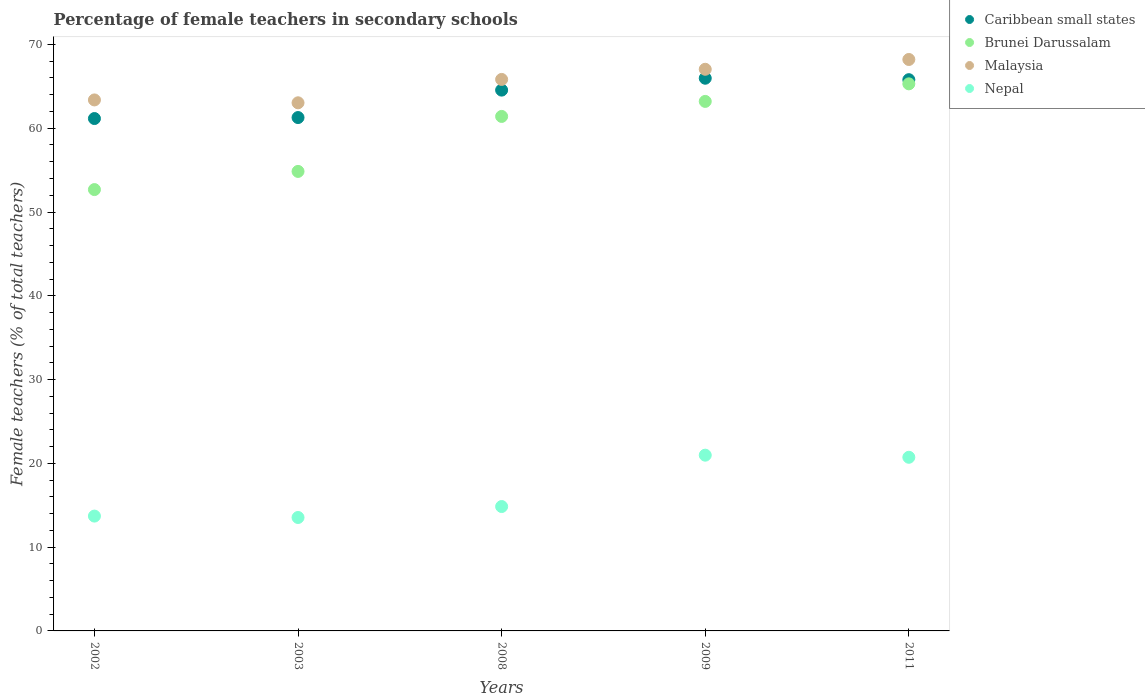How many different coloured dotlines are there?
Keep it short and to the point. 4. Is the number of dotlines equal to the number of legend labels?
Provide a short and direct response. Yes. What is the percentage of female teachers in Nepal in 2008?
Your answer should be very brief. 14.85. Across all years, what is the maximum percentage of female teachers in Malaysia?
Your answer should be compact. 68.21. Across all years, what is the minimum percentage of female teachers in Malaysia?
Keep it short and to the point. 63.04. In which year was the percentage of female teachers in Caribbean small states maximum?
Your answer should be very brief. 2009. What is the total percentage of female teachers in Caribbean small states in the graph?
Make the answer very short. 318.75. What is the difference between the percentage of female teachers in Caribbean small states in 2003 and that in 2008?
Your answer should be compact. -3.28. What is the difference between the percentage of female teachers in Nepal in 2009 and the percentage of female teachers in Malaysia in 2008?
Give a very brief answer. -44.85. What is the average percentage of female teachers in Brunei Darussalam per year?
Offer a very short reply. 59.49. In the year 2009, what is the difference between the percentage of female teachers in Caribbean small states and percentage of female teachers in Nepal?
Keep it short and to the point. 44.99. In how many years, is the percentage of female teachers in Brunei Darussalam greater than 56 %?
Offer a very short reply. 3. What is the ratio of the percentage of female teachers in Nepal in 2002 to that in 2008?
Keep it short and to the point. 0.92. Is the percentage of female teachers in Caribbean small states in 2002 less than that in 2009?
Make the answer very short. Yes. Is the difference between the percentage of female teachers in Caribbean small states in 2003 and 2009 greater than the difference between the percentage of female teachers in Nepal in 2003 and 2009?
Provide a succinct answer. Yes. What is the difference between the highest and the second highest percentage of female teachers in Malaysia?
Provide a succinct answer. 1.17. What is the difference between the highest and the lowest percentage of female teachers in Nepal?
Provide a short and direct response. 7.44. In how many years, is the percentage of female teachers in Malaysia greater than the average percentage of female teachers in Malaysia taken over all years?
Make the answer very short. 3. Is the sum of the percentage of female teachers in Malaysia in 2008 and 2009 greater than the maximum percentage of female teachers in Brunei Darussalam across all years?
Your response must be concise. Yes. Is it the case that in every year, the sum of the percentage of female teachers in Nepal and percentage of female teachers in Malaysia  is greater than the percentage of female teachers in Brunei Darussalam?
Make the answer very short. Yes. How many dotlines are there?
Your answer should be compact. 4. How many years are there in the graph?
Your answer should be compact. 5. Are the values on the major ticks of Y-axis written in scientific E-notation?
Offer a terse response. No. What is the title of the graph?
Give a very brief answer. Percentage of female teachers in secondary schools. Does "Costa Rica" appear as one of the legend labels in the graph?
Provide a succinct answer. No. What is the label or title of the Y-axis?
Make the answer very short. Female teachers (% of total teachers). What is the Female teachers (% of total teachers) in Caribbean small states in 2002?
Ensure brevity in your answer.  61.16. What is the Female teachers (% of total teachers) of Brunei Darussalam in 2002?
Your response must be concise. 52.68. What is the Female teachers (% of total teachers) of Malaysia in 2002?
Your answer should be very brief. 63.38. What is the Female teachers (% of total teachers) of Nepal in 2002?
Your answer should be compact. 13.71. What is the Female teachers (% of total teachers) of Caribbean small states in 2003?
Your answer should be very brief. 61.28. What is the Female teachers (% of total teachers) in Brunei Darussalam in 2003?
Offer a very short reply. 54.85. What is the Female teachers (% of total teachers) in Malaysia in 2003?
Make the answer very short. 63.04. What is the Female teachers (% of total teachers) of Nepal in 2003?
Ensure brevity in your answer.  13.54. What is the Female teachers (% of total teachers) in Caribbean small states in 2008?
Provide a short and direct response. 64.55. What is the Female teachers (% of total teachers) of Brunei Darussalam in 2008?
Provide a short and direct response. 61.41. What is the Female teachers (% of total teachers) in Malaysia in 2008?
Provide a short and direct response. 65.83. What is the Female teachers (% of total teachers) of Nepal in 2008?
Give a very brief answer. 14.85. What is the Female teachers (% of total teachers) in Caribbean small states in 2009?
Your response must be concise. 65.97. What is the Female teachers (% of total teachers) of Brunei Darussalam in 2009?
Make the answer very short. 63.2. What is the Female teachers (% of total teachers) of Malaysia in 2009?
Offer a terse response. 67.04. What is the Female teachers (% of total teachers) of Nepal in 2009?
Provide a succinct answer. 20.98. What is the Female teachers (% of total teachers) of Caribbean small states in 2011?
Keep it short and to the point. 65.8. What is the Female teachers (% of total teachers) in Brunei Darussalam in 2011?
Make the answer very short. 65.3. What is the Female teachers (% of total teachers) in Malaysia in 2011?
Give a very brief answer. 68.21. What is the Female teachers (% of total teachers) in Nepal in 2011?
Ensure brevity in your answer.  20.73. Across all years, what is the maximum Female teachers (% of total teachers) of Caribbean small states?
Offer a very short reply. 65.97. Across all years, what is the maximum Female teachers (% of total teachers) of Brunei Darussalam?
Offer a very short reply. 65.3. Across all years, what is the maximum Female teachers (% of total teachers) in Malaysia?
Make the answer very short. 68.21. Across all years, what is the maximum Female teachers (% of total teachers) in Nepal?
Provide a succinct answer. 20.98. Across all years, what is the minimum Female teachers (% of total teachers) of Caribbean small states?
Provide a succinct answer. 61.16. Across all years, what is the minimum Female teachers (% of total teachers) of Brunei Darussalam?
Your answer should be very brief. 52.68. Across all years, what is the minimum Female teachers (% of total teachers) in Malaysia?
Provide a short and direct response. 63.04. Across all years, what is the minimum Female teachers (% of total teachers) of Nepal?
Make the answer very short. 13.54. What is the total Female teachers (% of total teachers) in Caribbean small states in the graph?
Offer a terse response. 318.75. What is the total Female teachers (% of total teachers) of Brunei Darussalam in the graph?
Ensure brevity in your answer.  297.44. What is the total Female teachers (% of total teachers) in Malaysia in the graph?
Provide a succinct answer. 327.49. What is the total Female teachers (% of total teachers) of Nepal in the graph?
Your answer should be compact. 83.8. What is the difference between the Female teachers (% of total teachers) in Caribbean small states in 2002 and that in 2003?
Your response must be concise. -0.12. What is the difference between the Female teachers (% of total teachers) of Brunei Darussalam in 2002 and that in 2003?
Provide a short and direct response. -2.17. What is the difference between the Female teachers (% of total teachers) of Malaysia in 2002 and that in 2003?
Your answer should be very brief. 0.34. What is the difference between the Female teachers (% of total teachers) of Nepal in 2002 and that in 2003?
Your answer should be compact. 0.17. What is the difference between the Female teachers (% of total teachers) in Caribbean small states in 2002 and that in 2008?
Offer a terse response. -3.39. What is the difference between the Female teachers (% of total teachers) in Brunei Darussalam in 2002 and that in 2008?
Provide a succinct answer. -8.73. What is the difference between the Female teachers (% of total teachers) of Malaysia in 2002 and that in 2008?
Offer a terse response. -2.45. What is the difference between the Female teachers (% of total teachers) in Nepal in 2002 and that in 2008?
Offer a terse response. -1.14. What is the difference between the Female teachers (% of total teachers) in Caribbean small states in 2002 and that in 2009?
Make the answer very short. -4.81. What is the difference between the Female teachers (% of total teachers) of Brunei Darussalam in 2002 and that in 2009?
Provide a succinct answer. -10.52. What is the difference between the Female teachers (% of total teachers) of Malaysia in 2002 and that in 2009?
Make the answer very short. -3.66. What is the difference between the Female teachers (% of total teachers) of Nepal in 2002 and that in 2009?
Ensure brevity in your answer.  -7.27. What is the difference between the Female teachers (% of total teachers) in Caribbean small states in 2002 and that in 2011?
Give a very brief answer. -4.64. What is the difference between the Female teachers (% of total teachers) of Brunei Darussalam in 2002 and that in 2011?
Provide a short and direct response. -12.62. What is the difference between the Female teachers (% of total teachers) in Malaysia in 2002 and that in 2011?
Ensure brevity in your answer.  -4.83. What is the difference between the Female teachers (% of total teachers) in Nepal in 2002 and that in 2011?
Give a very brief answer. -7.02. What is the difference between the Female teachers (% of total teachers) of Caribbean small states in 2003 and that in 2008?
Your answer should be very brief. -3.28. What is the difference between the Female teachers (% of total teachers) in Brunei Darussalam in 2003 and that in 2008?
Make the answer very short. -6.56. What is the difference between the Female teachers (% of total teachers) of Malaysia in 2003 and that in 2008?
Your answer should be very brief. -2.79. What is the difference between the Female teachers (% of total teachers) of Nepal in 2003 and that in 2008?
Ensure brevity in your answer.  -1.31. What is the difference between the Female teachers (% of total teachers) in Caribbean small states in 2003 and that in 2009?
Offer a terse response. -4.69. What is the difference between the Female teachers (% of total teachers) in Brunei Darussalam in 2003 and that in 2009?
Provide a short and direct response. -8.36. What is the difference between the Female teachers (% of total teachers) of Malaysia in 2003 and that in 2009?
Provide a short and direct response. -4. What is the difference between the Female teachers (% of total teachers) of Nepal in 2003 and that in 2009?
Offer a terse response. -7.44. What is the difference between the Female teachers (% of total teachers) of Caribbean small states in 2003 and that in 2011?
Make the answer very short. -4.52. What is the difference between the Female teachers (% of total teachers) in Brunei Darussalam in 2003 and that in 2011?
Offer a terse response. -10.45. What is the difference between the Female teachers (% of total teachers) in Malaysia in 2003 and that in 2011?
Ensure brevity in your answer.  -5.17. What is the difference between the Female teachers (% of total teachers) in Nepal in 2003 and that in 2011?
Make the answer very short. -7.19. What is the difference between the Female teachers (% of total teachers) of Caribbean small states in 2008 and that in 2009?
Give a very brief answer. -1.42. What is the difference between the Female teachers (% of total teachers) in Brunei Darussalam in 2008 and that in 2009?
Your answer should be compact. -1.79. What is the difference between the Female teachers (% of total teachers) of Malaysia in 2008 and that in 2009?
Your answer should be very brief. -1.21. What is the difference between the Female teachers (% of total teachers) in Nepal in 2008 and that in 2009?
Make the answer very short. -6.13. What is the difference between the Female teachers (% of total teachers) in Caribbean small states in 2008 and that in 2011?
Your answer should be compact. -1.25. What is the difference between the Female teachers (% of total teachers) in Brunei Darussalam in 2008 and that in 2011?
Ensure brevity in your answer.  -3.89. What is the difference between the Female teachers (% of total teachers) in Malaysia in 2008 and that in 2011?
Ensure brevity in your answer.  -2.38. What is the difference between the Female teachers (% of total teachers) in Nepal in 2008 and that in 2011?
Your response must be concise. -5.88. What is the difference between the Female teachers (% of total teachers) in Caribbean small states in 2009 and that in 2011?
Keep it short and to the point. 0.17. What is the difference between the Female teachers (% of total teachers) of Brunei Darussalam in 2009 and that in 2011?
Your response must be concise. -2.1. What is the difference between the Female teachers (% of total teachers) of Malaysia in 2009 and that in 2011?
Keep it short and to the point. -1.17. What is the difference between the Female teachers (% of total teachers) in Nepal in 2009 and that in 2011?
Provide a succinct answer. 0.25. What is the difference between the Female teachers (% of total teachers) of Caribbean small states in 2002 and the Female teachers (% of total teachers) of Brunei Darussalam in 2003?
Your answer should be very brief. 6.31. What is the difference between the Female teachers (% of total teachers) in Caribbean small states in 2002 and the Female teachers (% of total teachers) in Malaysia in 2003?
Keep it short and to the point. -1.88. What is the difference between the Female teachers (% of total teachers) of Caribbean small states in 2002 and the Female teachers (% of total teachers) of Nepal in 2003?
Keep it short and to the point. 47.62. What is the difference between the Female teachers (% of total teachers) of Brunei Darussalam in 2002 and the Female teachers (% of total teachers) of Malaysia in 2003?
Provide a short and direct response. -10.36. What is the difference between the Female teachers (% of total teachers) in Brunei Darussalam in 2002 and the Female teachers (% of total teachers) in Nepal in 2003?
Your response must be concise. 39.14. What is the difference between the Female teachers (% of total teachers) in Malaysia in 2002 and the Female teachers (% of total teachers) in Nepal in 2003?
Keep it short and to the point. 49.84. What is the difference between the Female teachers (% of total teachers) of Caribbean small states in 2002 and the Female teachers (% of total teachers) of Brunei Darussalam in 2008?
Your response must be concise. -0.25. What is the difference between the Female teachers (% of total teachers) in Caribbean small states in 2002 and the Female teachers (% of total teachers) in Malaysia in 2008?
Ensure brevity in your answer.  -4.67. What is the difference between the Female teachers (% of total teachers) in Caribbean small states in 2002 and the Female teachers (% of total teachers) in Nepal in 2008?
Make the answer very short. 46.31. What is the difference between the Female teachers (% of total teachers) in Brunei Darussalam in 2002 and the Female teachers (% of total teachers) in Malaysia in 2008?
Give a very brief answer. -13.15. What is the difference between the Female teachers (% of total teachers) of Brunei Darussalam in 2002 and the Female teachers (% of total teachers) of Nepal in 2008?
Ensure brevity in your answer.  37.83. What is the difference between the Female teachers (% of total teachers) in Malaysia in 2002 and the Female teachers (% of total teachers) in Nepal in 2008?
Offer a terse response. 48.53. What is the difference between the Female teachers (% of total teachers) in Caribbean small states in 2002 and the Female teachers (% of total teachers) in Brunei Darussalam in 2009?
Provide a short and direct response. -2.05. What is the difference between the Female teachers (% of total teachers) in Caribbean small states in 2002 and the Female teachers (% of total teachers) in Malaysia in 2009?
Offer a very short reply. -5.88. What is the difference between the Female teachers (% of total teachers) of Caribbean small states in 2002 and the Female teachers (% of total teachers) of Nepal in 2009?
Your answer should be very brief. 40.18. What is the difference between the Female teachers (% of total teachers) in Brunei Darussalam in 2002 and the Female teachers (% of total teachers) in Malaysia in 2009?
Your response must be concise. -14.36. What is the difference between the Female teachers (% of total teachers) of Brunei Darussalam in 2002 and the Female teachers (% of total teachers) of Nepal in 2009?
Your response must be concise. 31.7. What is the difference between the Female teachers (% of total teachers) of Malaysia in 2002 and the Female teachers (% of total teachers) of Nepal in 2009?
Give a very brief answer. 42.4. What is the difference between the Female teachers (% of total teachers) of Caribbean small states in 2002 and the Female teachers (% of total teachers) of Brunei Darussalam in 2011?
Your answer should be very brief. -4.14. What is the difference between the Female teachers (% of total teachers) of Caribbean small states in 2002 and the Female teachers (% of total teachers) of Malaysia in 2011?
Provide a short and direct response. -7.05. What is the difference between the Female teachers (% of total teachers) in Caribbean small states in 2002 and the Female teachers (% of total teachers) in Nepal in 2011?
Give a very brief answer. 40.43. What is the difference between the Female teachers (% of total teachers) in Brunei Darussalam in 2002 and the Female teachers (% of total teachers) in Malaysia in 2011?
Your response must be concise. -15.53. What is the difference between the Female teachers (% of total teachers) in Brunei Darussalam in 2002 and the Female teachers (% of total teachers) in Nepal in 2011?
Make the answer very short. 31.95. What is the difference between the Female teachers (% of total teachers) of Malaysia in 2002 and the Female teachers (% of total teachers) of Nepal in 2011?
Make the answer very short. 42.65. What is the difference between the Female teachers (% of total teachers) of Caribbean small states in 2003 and the Female teachers (% of total teachers) of Brunei Darussalam in 2008?
Give a very brief answer. -0.13. What is the difference between the Female teachers (% of total teachers) of Caribbean small states in 2003 and the Female teachers (% of total teachers) of Malaysia in 2008?
Provide a short and direct response. -4.55. What is the difference between the Female teachers (% of total teachers) in Caribbean small states in 2003 and the Female teachers (% of total teachers) in Nepal in 2008?
Your answer should be very brief. 46.43. What is the difference between the Female teachers (% of total teachers) in Brunei Darussalam in 2003 and the Female teachers (% of total teachers) in Malaysia in 2008?
Your answer should be very brief. -10.98. What is the difference between the Female teachers (% of total teachers) of Brunei Darussalam in 2003 and the Female teachers (% of total teachers) of Nepal in 2008?
Make the answer very short. 40. What is the difference between the Female teachers (% of total teachers) of Malaysia in 2003 and the Female teachers (% of total teachers) of Nepal in 2008?
Provide a short and direct response. 48.19. What is the difference between the Female teachers (% of total teachers) in Caribbean small states in 2003 and the Female teachers (% of total teachers) in Brunei Darussalam in 2009?
Ensure brevity in your answer.  -1.93. What is the difference between the Female teachers (% of total teachers) in Caribbean small states in 2003 and the Female teachers (% of total teachers) in Malaysia in 2009?
Ensure brevity in your answer.  -5.76. What is the difference between the Female teachers (% of total teachers) of Caribbean small states in 2003 and the Female teachers (% of total teachers) of Nepal in 2009?
Give a very brief answer. 40.3. What is the difference between the Female teachers (% of total teachers) of Brunei Darussalam in 2003 and the Female teachers (% of total teachers) of Malaysia in 2009?
Your answer should be very brief. -12.19. What is the difference between the Female teachers (% of total teachers) of Brunei Darussalam in 2003 and the Female teachers (% of total teachers) of Nepal in 2009?
Make the answer very short. 33.87. What is the difference between the Female teachers (% of total teachers) in Malaysia in 2003 and the Female teachers (% of total teachers) in Nepal in 2009?
Your answer should be very brief. 42.06. What is the difference between the Female teachers (% of total teachers) of Caribbean small states in 2003 and the Female teachers (% of total teachers) of Brunei Darussalam in 2011?
Your answer should be compact. -4.02. What is the difference between the Female teachers (% of total teachers) in Caribbean small states in 2003 and the Female teachers (% of total teachers) in Malaysia in 2011?
Provide a short and direct response. -6.93. What is the difference between the Female teachers (% of total teachers) in Caribbean small states in 2003 and the Female teachers (% of total teachers) in Nepal in 2011?
Provide a succinct answer. 40.55. What is the difference between the Female teachers (% of total teachers) of Brunei Darussalam in 2003 and the Female teachers (% of total teachers) of Malaysia in 2011?
Ensure brevity in your answer.  -13.36. What is the difference between the Female teachers (% of total teachers) in Brunei Darussalam in 2003 and the Female teachers (% of total teachers) in Nepal in 2011?
Ensure brevity in your answer.  34.12. What is the difference between the Female teachers (% of total teachers) in Malaysia in 2003 and the Female teachers (% of total teachers) in Nepal in 2011?
Your answer should be very brief. 42.31. What is the difference between the Female teachers (% of total teachers) of Caribbean small states in 2008 and the Female teachers (% of total teachers) of Brunei Darussalam in 2009?
Offer a very short reply. 1.35. What is the difference between the Female teachers (% of total teachers) of Caribbean small states in 2008 and the Female teachers (% of total teachers) of Malaysia in 2009?
Give a very brief answer. -2.49. What is the difference between the Female teachers (% of total teachers) in Caribbean small states in 2008 and the Female teachers (% of total teachers) in Nepal in 2009?
Provide a short and direct response. 43.57. What is the difference between the Female teachers (% of total teachers) of Brunei Darussalam in 2008 and the Female teachers (% of total teachers) of Malaysia in 2009?
Your answer should be compact. -5.63. What is the difference between the Female teachers (% of total teachers) of Brunei Darussalam in 2008 and the Female teachers (% of total teachers) of Nepal in 2009?
Your answer should be compact. 40.43. What is the difference between the Female teachers (% of total teachers) of Malaysia in 2008 and the Female teachers (% of total teachers) of Nepal in 2009?
Your response must be concise. 44.85. What is the difference between the Female teachers (% of total teachers) in Caribbean small states in 2008 and the Female teachers (% of total teachers) in Brunei Darussalam in 2011?
Your answer should be compact. -0.75. What is the difference between the Female teachers (% of total teachers) of Caribbean small states in 2008 and the Female teachers (% of total teachers) of Malaysia in 2011?
Provide a succinct answer. -3.66. What is the difference between the Female teachers (% of total teachers) in Caribbean small states in 2008 and the Female teachers (% of total teachers) in Nepal in 2011?
Make the answer very short. 43.83. What is the difference between the Female teachers (% of total teachers) of Brunei Darussalam in 2008 and the Female teachers (% of total teachers) of Malaysia in 2011?
Make the answer very short. -6.8. What is the difference between the Female teachers (% of total teachers) in Brunei Darussalam in 2008 and the Female teachers (% of total teachers) in Nepal in 2011?
Your answer should be very brief. 40.68. What is the difference between the Female teachers (% of total teachers) in Malaysia in 2008 and the Female teachers (% of total teachers) in Nepal in 2011?
Keep it short and to the point. 45.1. What is the difference between the Female teachers (% of total teachers) in Caribbean small states in 2009 and the Female teachers (% of total teachers) in Brunei Darussalam in 2011?
Ensure brevity in your answer.  0.67. What is the difference between the Female teachers (% of total teachers) in Caribbean small states in 2009 and the Female teachers (% of total teachers) in Malaysia in 2011?
Your answer should be compact. -2.24. What is the difference between the Female teachers (% of total teachers) of Caribbean small states in 2009 and the Female teachers (% of total teachers) of Nepal in 2011?
Your answer should be very brief. 45.24. What is the difference between the Female teachers (% of total teachers) of Brunei Darussalam in 2009 and the Female teachers (% of total teachers) of Malaysia in 2011?
Provide a short and direct response. -5. What is the difference between the Female teachers (% of total teachers) of Brunei Darussalam in 2009 and the Female teachers (% of total teachers) of Nepal in 2011?
Your answer should be compact. 42.48. What is the difference between the Female teachers (% of total teachers) in Malaysia in 2009 and the Female teachers (% of total teachers) in Nepal in 2011?
Your answer should be compact. 46.31. What is the average Female teachers (% of total teachers) of Caribbean small states per year?
Ensure brevity in your answer.  63.75. What is the average Female teachers (% of total teachers) in Brunei Darussalam per year?
Keep it short and to the point. 59.49. What is the average Female teachers (% of total teachers) in Malaysia per year?
Make the answer very short. 65.5. What is the average Female teachers (% of total teachers) of Nepal per year?
Give a very brief answer. 16.76. In the year 2002, what is the difference between the Female teachers (% of total teachers) in Caribbean small states and Female teachers (% of total teachers) in Brunei Darussalam?
Your answer should be very brief. 8.48. In the year 2002, what is the difference between the Female teachers (% of total teachers) in Caribbean small states and Female teachers (% of total teachers) in Malaysia?
Your answer should be very brief. -2.22. In the year 2002, what is the difference between the Female teachers (% of total teachers) of Caribbean small states and Female teachers (% of total teachers) of Nepal?
Provide a short and direct response. 47.45. In the year 2002, what is the difference between the Female teachers (% of total teachers) of Brunei Darussalam and Female teachers (% of total teachers) of Malaysia?
Provide a short and direct response. -10.7. In the year 2002, what is the difference between the Female teachers (% of total teachers) of Brunei Darussalam and Female teachers (% of total teachers) of Nepal?
Provide a short and direct response. 38.97. In the year 2002, what is the difference between the Female teachers (% of total teachers) in Malaysia and Female teachers (% of total teachers) in Nepal?
Your response must be concise. 49.67. In the year 2003, what is the difference between the Female teachers (% of total teachers) in Caribbean small states and Female teachers (% of total teachers) in Brunei Darussalam?
Ensure brevity in your answer.  6.43. In the year 2003, what is the difference between the Female teachers (% of total teachers) of Caribbean small states and Female teachers (% of total teachers) of Malaysia?
Offer a very short reply. -1.76. In the year 2003, what is the difference between the Female teachers (% of total teachers) in Caribbean small states and Female teachers (% of total teachers) in Nepal?
Offer a terse response. 47.74. In the year 2003, what is the difference between the Female teachers (% of total teachers) of Brunei Darussalam and Female teachers (% of total teachers) of Malaysia?
Provide a succinct answer. -8.19. In the year 2003, what is the difference between the Female teachers (% of total teachers) in Brunei Darussalam and Female teachers (% of total teachers) in Nepal?
Ensure brevity in your answer.  41.31. In the year 2003, what is the difference between the Female teachers (% of total teachers) of Malaysia and Female teachers (% of total teachers) of Nepal?
Ensure brevity in your answer.  49.5. In the year 2008, what is the difference between the Female teachers (% of total teachers) of Caribbean small states and Female teachers (% of total teachers) of Brunei Darussalam?
Keep it short and to the point. 3.14. In the year 2008, what is the difference between the Female teachers (% of total teachers) in Caribbean small states and Female teachers (% of total teachers) in Malaysia?
Your answer should be compact. -1.27. In the year 2008, what is the difference between the Female teachers (% of total teachers) in Caribbean small states and Female teachers (% of total teachers) in Nepal?
Keep it short and to the point. 49.7. In the year 2008, what is the difference between the Female teachers (% of total teachers) of Brunei Darussalam and Female teachers (% of total teachers) of Malaysia?
Provide a succinct answer. -4.42. In the year 2008, what is the difference between the Female teachers (% of total teachers) in Brunei Darussalam and Female teachers (% of total teachers) in Nepal?
Make the answer very short. 46.56. In the year 2008, what is the difference between the Female teachers (% of total teachers) of Malaysia and Female teachers (% of total teachers) of Nepal?
Offer a very short reply. 50.98. In the year 2009, what is the difference between the Female teachers (% of total teachers) of Caribbean small states and Female teachers (% of total teachers) of Brunei Darussalam?
Provide a succinct answer. 2.77. In the year 2009, what is the difference between the Female teachers (% of total teachers) in Caribbean small states and Female teachers (% of total teachers) in Malaysia?
Your answer should be compact. -1.07. In the year 2009, what is the difference between the Female teachers (% of total teachers) of Caribbean small states and Female teachers (% of total teachers) of Nepal?
Your answer should be very brief. 44.99. In the year 2009, what is the difference between the Female teachers (% of total teachers) of Brunei Darussalam and Female teachers (% of total teachers) of Malaysia?
Offer a terse response. -3.83. In the year 2009, what is the difference between the Female teachers (% of total teachers) in Brunei Darussalam and Female teachers (% of total teachers) in Nepal?
Keep it short and to the point. 42.23. In the year 2009, what is the difference between the Female teachers (% of total teachers) in Malaysia and Female teachers (% of total teachers) in Nepal?
Offer a very short reply. 46.06. In the year 2011, what is the difference between the Female teachers (% of total teachers) of Caribbean small states and Female teachers (% of total teachers) of Brunei Darussalam?
Keep it short and to the point. 0.5. In the year 2011, what is the difference between the Female teachers (% of total teachers) in Caribbean small states and Female teachers (% of total teachers) in Malaysia?
Your answer should be compact. -2.41. In the year 2011, what is the difference between the Female teachers (% of total teachers) in Caribbean small states and Female teachers (% of total teachers) in Nepal?
Offer a very short reply. 45.07. In the year 2011, what is the difference between the Female teachers (% of total teachers) in Brunei Darussalam and Female teachers (% of total teachers) in Malaysia?
Ensure brevity in your answer.  -2.91. In the year 2011, what is the difference between the Female teachers (% of total teachers) in Brunei Darussalam and Female teachers (% of total teachers) in Nepal?
Offer a terse response. 44.57. In the year 2011, what is the difference between the Female teachers (% of total teachers) of Malaysia and Female teachers (% of total teachers) of Nepal?
Keep it short and to the point. 47.48. What is the ratio of the Female teachers (% of total teachers) in Brunei Darussalam in 2002 to that in 2003?
Give a very brief answer. 0.96. What is the ratio of the Female teachers (% of total teachers) of Malaysia in 2002 to that in 2003?
Keep it short and to the point. 1.01. What is the ratio of the Female teachers (% of total teachers) in Nepal in 2002 to that in 2003?
Your answer should be compact. 1.01. What is the ratio of the Female teachers (% of total teachers) of Caribbean small states in 2002 to that in 2008?
Offer a very short reply. 0.95. What is the ratio of the Female teachers (% of total teachers) in Brunei Darussalam in 2002 to that in 2008?
Your answer should be compact. 0.86. What is the ratio of the Female teachers (% of total teachers) in Malaysia in 2002 to that in 2008?
Offer a very short reply. 0.96. What is the ratio of the Female teachers (% of total teachers) in Nepal in 2002 to that in 2008?
Ensure brevity in your answer.  0.92. What is the ratio of the Female teachers (% of total teachers) in Caribbean small states in 2002 to that in 2009?
Provide a succinct answer. 0.93. What is the ratio of the Female teachers (% of total teachers) in Brunei Darussalam in 2002 to that in 2009?
Your answer should be compact. 0.83. What is the ratio of the Female teachers (% of total teachers) in Malaysia in 2002 to that in 2009?
Your answer should be very brief. 0.95. What is the ratio of the Female teachers (% of total teachers) of Nepal in 2002 to that in 2009?
Offer a very short reply. 0.65. What is the ratio of the Female teachers (% of total teachers) in Caribbean small states in 2002 to that in 2011?
Give a very brief answer. 0.93. What is the ratio of the Female teachers (% of total teachers) in Brunei Darussalam in 2002 to that in 2011?
Your response must be concise. 0.81. What is the ratio of the Female teachers (% of total teachers) in Malaysia in 2002 to that in 2011?
Offer a very short reply. 0.93. What is the ratio of the Female teachers (% of total teachers) of Nepal in 2002 to that in 2011?
Offer a very short reply. 0.66. What is the ratio of the Female teachers (% of total teachers) in Caribbean small states in 2003 to that in 2008?
Keep it short and to the point. 0.95. What is the ratio of the Female teachers (% of total teachers) of Brunei Darussalam in 2003 to that in 2008?
Offer a terse response. 0.89. What is the ratio of the Female teachers (% of total teachers) of Malaysia in 2003 to that in 2008?
Your response must be concise. 0.96. What is the ratio of the Female teachers (% of total teachers) in Nepal in 2003 to that in 2008?
Your answer should be very brief. 0.91. What is the ratio of the Female teachers (% of total teachers) of Caribbean small states in 2003 to that in 2009?
Your answer should be compact. 0.93. What is the ratio of the Female teachers (% of total teachers) in Brunei Darussalam in 2003 to that in 2009?
Give a very brief answer. 0.87. What is the ratio of the Female teachers (% of total teachers) in Malaysia in 2003 to that in 2009?
Offer a terse response. 0.94. What is the ratio of the Female teachers (% of total teachers) in Nepal in 2003 to that in 2009?
Offer a terse response. 0.65. What is the ratio of the Female teachers (% of total teachers) in Caribbean small states in 2003 to that in 2011?
Offer a very short reply. 0.93. What is the ratio of the Female teachers (% of total teachers) of Brunei Darussalam in 2003 to that in 2011?
Offer a terse response. 0.84. What is the ratio of the Female teachers (% of total teachers) of Malaysia in 2003 to that in 2011?
Give a very brief answer. 0.92. What is the ratio of the Female teachers (% of total teachers) in Nepal in 2003 to that in 2011?
Ensure brevity in your answer.  0.65. What is the ratio of the Female teachers (% of total teachers) of Caribbean small states in 2008 to that in 2009?
Give a very brief answer. 0.98. What is the ratio of the Female teachers (% of total teachers) in Brunei Darussalam in 2008 to that in 2009?
Ensure brevity in your answer.  0.97. What is the ratio of the Female teachers (% of total teachers) of Malaysia in 2008 to that in 2009?
Offer a terse response. 0.98. What is the ratio of the Female teachers (% of total teachers) of Nepal in 2008 to that in 2009?
Your response must be concise. 0.71. What is the ratio of the Female teachers (% of total teachers) in Caribbean small states in 2008 to that in 2011?
Make the answer very short. 0.98. What is the ratio of the Female teachers (% of total teachers) in Brunei Darussalam in 2008 to that in 2011?
Offer a terse response. 0.94. What is the ratio of the Female teachers (% of total teachers) in Malaysia in 2008 to that in 2011?
Your answer should be compact. 0.97. What is the ratio of the Female teachers (% of total teachers) of Nepal in 2008 to that in 2011?
Your response must be concise. 0.72. What is the ratio of the Female teachers (% of total teachers) of Brunei Darussalam in 2009 to that in 2011?
Make the answer very short. 0.97. What is the ratio of the Female teachers (% of total teachers) in Malaysia in 2009 to that in 2011?
Provide a succinct answer. 0.98. What is the ratio of the Female teachers (% of total teachers) of Nepal in 2009 to that in 2011?
Offer a terse response. 1.01. What is the difference between the highest and the second highest Female teachers (% of total teachers) of Caribbean small states?
Your response must be concise. 0.17. What is the difference between the highest and the second highest Female teachers (% of total teachers) in Brunei Darussalam?
Make the answer very short. 2.1. What is the difference between the highest and the second highest Female teachers (% of total teachers) of Malaysia?
Make the answer very short. 1.17. What is the difference between the highest and the second highest Female teachers (% of total teachers) of Nepal?
Offer a very short reply. 0.25. What is the difference between the highest and the lowest Female teachers (% of total teachers) in Caribbean small states?
Provide a short and direct response. 4.81. What is the difference between the highest and the lowest Female teachers (% of total teachers) in Brunei Darussalam?
Your response must be concise. 12.62. What is the difference between the highest and the lowest Female teachers (% of total teachers) in Malaysia?
Your response must be concise. 5.17. What is the difference between the highest and the lowest Female teachers (% of total teachers) in Nepal?
Your response must be concise. 7.44. 